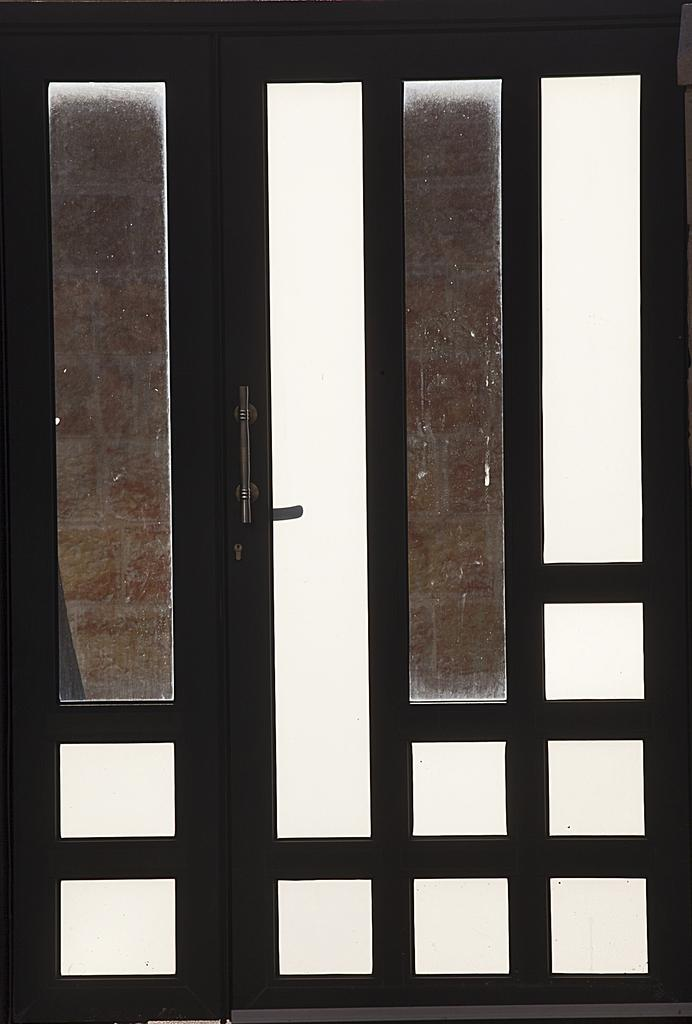What is located in the center of the image? There is a door in the center of the image. What feature is present on the door? There is a handle on the door. What type of crime is being committed in the image? There is no indication of any crime being committed in the image; it simply features a door with a handle. What role does the drain play in the image? There is no drain present in the image. How does the tramp fit into the scene depicted in the image? There is no tramp present in the image. 